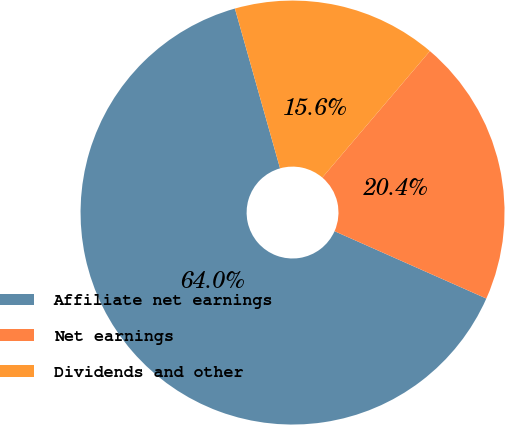<chart> <loc_0><loc_0><loc_500><loc_500><pie_chart><fcel>Affiliate net earnings<fcel>Net earnings<fcel>Dividends and other<nl><fcel>63.97%<fcel>20.43%<fcel>15.6%<nl></chart> 